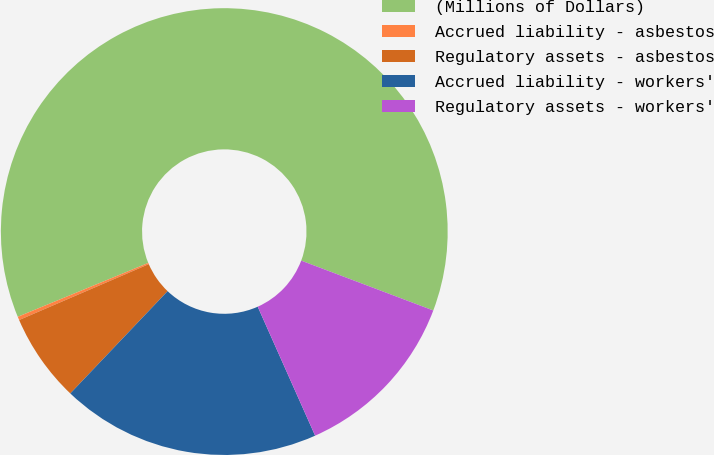Convert chart to OTSL. <chart><loc_0><loc_0><loc_500><loc_500><pie_chart><fcel>(Millions of Dollars)<fcel>Accrued liability - asbestos<fcel>Regulatory assets - asbestos<fcel>Accrued liability - workers'<fcel>Regulatory assets - workers'<nl><fcel>61.98%<fcel>0.25%<fcel>6.42%<fcel>18.77%<fcel>12.59%<nl></chart> 